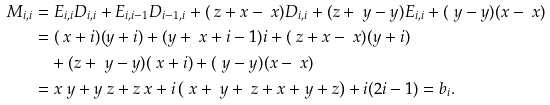Convert formula to latex. <formula><loc_0><loc_0><loc_500><loc_500>M _ { i , i } & = E _ { i , i } D _ { i , i } + E _ { i , i - 1 } D _ { i - 1 , i } + ( \ z + x - \ x ) D _ { i , i } + ( z + \ y - y ) E _ { i , i } + ( \ y - y ) ( x - \ x ) & \\ & = ( \ x + i ) ( y + i ) + ( y + \ x + i - 1 ) i + ( \ z + x - \ x ) ( y + i ) \\ & \quad + ( z + \ y - y ) ( \ x + i ) + ( \ y - y ) ( x - \ x ) \\ & = x \ y + y \ z + z \ x + i \left ( \ x + \ y + \ z + x + y + z \right ) + i ( 2 i - 1 ) = b _ { i } .</formula> 